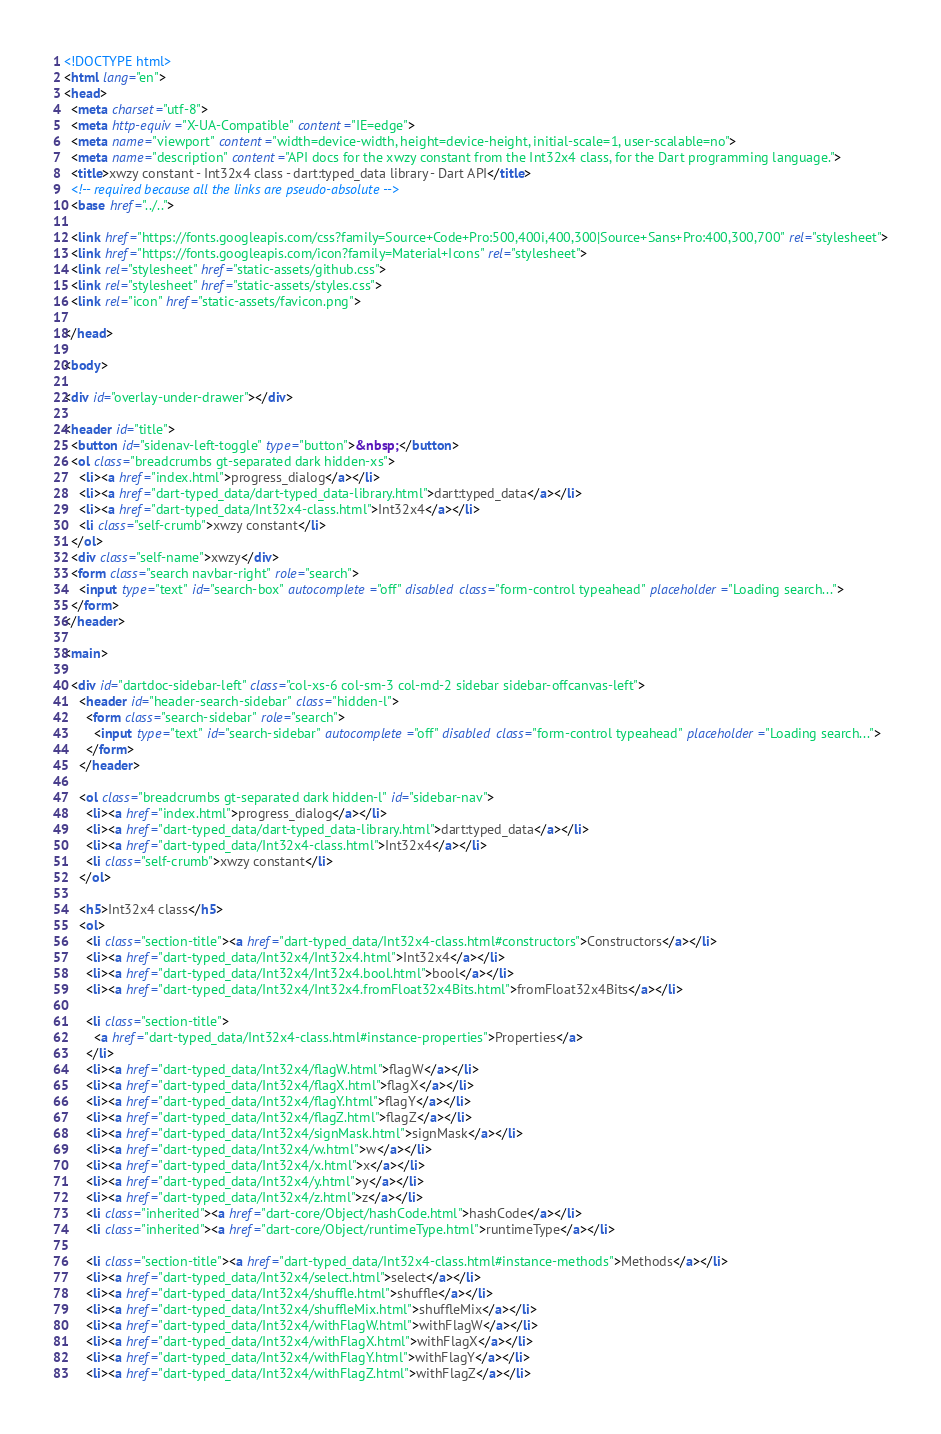Convert code to text. <code><loc_0><loc_0><loc_500><loc_500><_HTML_><!DOCTYPE html>
<html lang="en">
<head>
  <meta charset="utf-8">
  <meta http-equiv="X-UA-Compatible" content="IE=edge">
  <meta name="viewport" content="width=device-width, height=device-height, initial-scale=1, user-scalable=no">
  <meta name="description" content="API docs for the xwzy constant from the Int32x4 class, for the Dart programming language.">
  <title>xwzy constant - Int32x4 class - dart:typed_data library - Dart API</title>
  <!-- required because all the links are pseudo-absolute -->
  <base href="../..">

  <link href="https://fonts.googleapis.com/css?family=Source+Code+Pro:500,400i,400,300|Source+Sans+Pro:400,300,700" rel="stylesheet">
  <link href="https://fonts.googleapis.com/icon?family=Material+Icons" rel="stylesheet">
  <link rel="stylesheet" href="static-assets/github.css">
  <link rel="stylesheet" href="static-assets/styles.css">
  <link rel="icon" href="static-assets/favicon.png">
  
</head>

<body>

<div id="overlay-under-drawer"></div>

<header id="title">
  <button id="sidenav-left-toggle" type="button">&nbsp;</button>
  <ol class="breadcrumbs gt-separated dark hidden-xs">
    <li><a href="index.html">progress_dialog</a></li>
    <li><a href="dart-typed_data/dart-typed_data-library.html">dart:typed_data</a></li>
    <li><a href="dart-typed_data/Int32x4-class.html">Int32x4</a></li>
    <li class="self-crumb">xwzy constant</li>
  </ol>
  <div class="self-name">xwzy</div>
  <form class="search navbar-right" role="search">
    <input type="text" id="search-box" autocomplete="off" disabled class="form-control typeahead" placeholder="Loading search...">
  </form>
</header>

<main>

  <div id="dartdoc-sidebar-left" class="col-xs-6 col-sm-3 col-md-2 sidebar sidebar-offcanvas-left">
    <header id="header-search-sidebar" class="hidden-l">
      <form class="search-sidebar" role="search">
        <input type="text" id="search-sidebar" autocomplete="off" disabled class="form-control typeahead" placeholder="Loading search...">
      </form>
    </header>
    
    <ol class="breadcrumbs gt-separated dark hidden-l" id="sidebar-nav">
      <li><a href="index.html">progress_dialog</a></li>
      <li><a href="dart-typed_data/dart-typed_data-library.html">dart:typed_data</a></li>
      <li><a href="dart-typed_data/Int32x4-class.html">Int32x4</a></li>
      <li class="self-crumb">xwzy constant</li>
    </ol>
    
    <h5>Int32x4 class</h5>
    <ol>
      <li class="section-title"><a href="dart-typed_data/Int32x4-class.html#constructors">Constructors</a></li>
      <li><a href="dart-typed_data/Int32x4/Int32x4.html">Int32x4</a></li>
      <li><a href="dart-typed_data/Int32x4/Int32x4.bool.html">bool</a></li>
      <li><a href="dart-typed_data/Int32x4/Int32x4.fromFloat32x4Bits.html">fromFloat32x4Bits</a></li>
    
      <li class="section-title">
        <a href="dart-typed_data/Int32x4-class.html#instance-properties">Properties</a>
      </li>
      <li><a href="dart-typed_data/Int32x4/flagW.html">flagW</a></li>
      <li><a href="dart-typed_data/Int32x4/flagX.html">flagX</a></li>
      <li><a href="dart-typed_data/Int32x4/flagY.html">flagY</a></li>
      <li><a href="dart-typed_data/Int32x4/flagZ.html">flagZ</a></li>
      <li><a href="dart-typed_data/Int32x4/signMask.html">signMask</a></li>
      <li><a href="dart-typed_data/Int32x4/w.html">w</a></li>
      <li><a href="dart-typed_data/Int32x4/x.html">x</a></li>
      <li><a href="dart-typed_data/Int32x4/y.html">y</a></li>
      <li><a href="dart-typed_data/Int32x4/z.html">z</a></li>
      <li class="inherited"><a href="dart-core/Object/hashCode.html">hashCode</a></li>
      <li class="inherited"><a href="dart-core/Object/runtimeType.html">runtimeType</a></li>
    
      <li class="section-title"><a href="dart-typed_data/Int32x4-class.html#instance-methods">Methods</a></li>
      <li><a href="dart-typed_data/Int32x4/select.html">select</a></li>
      <li><a href="dart-typed_data/Int32x4/shuffle.html">shuffle</a></li>
      <li><a href="dart-typed_data/Int32x4/shuffleMix.html">shuffleMix</a></li>
      <li><a href="dart-typed_data/Int32x4/withFlagW.html">withFlagW</a></li>
      <li><a href="dart-typed_data/Int32x4/withFlagX.html">withFlagX</a></li>
      <li><a href="dart-typed_data/Int32x4/withFlagY.html">withFlagY</a></li>
      <li><a href="dart-typed_data/Int32x4/withFlagZ.html">withFlagZ</a></li></code> 